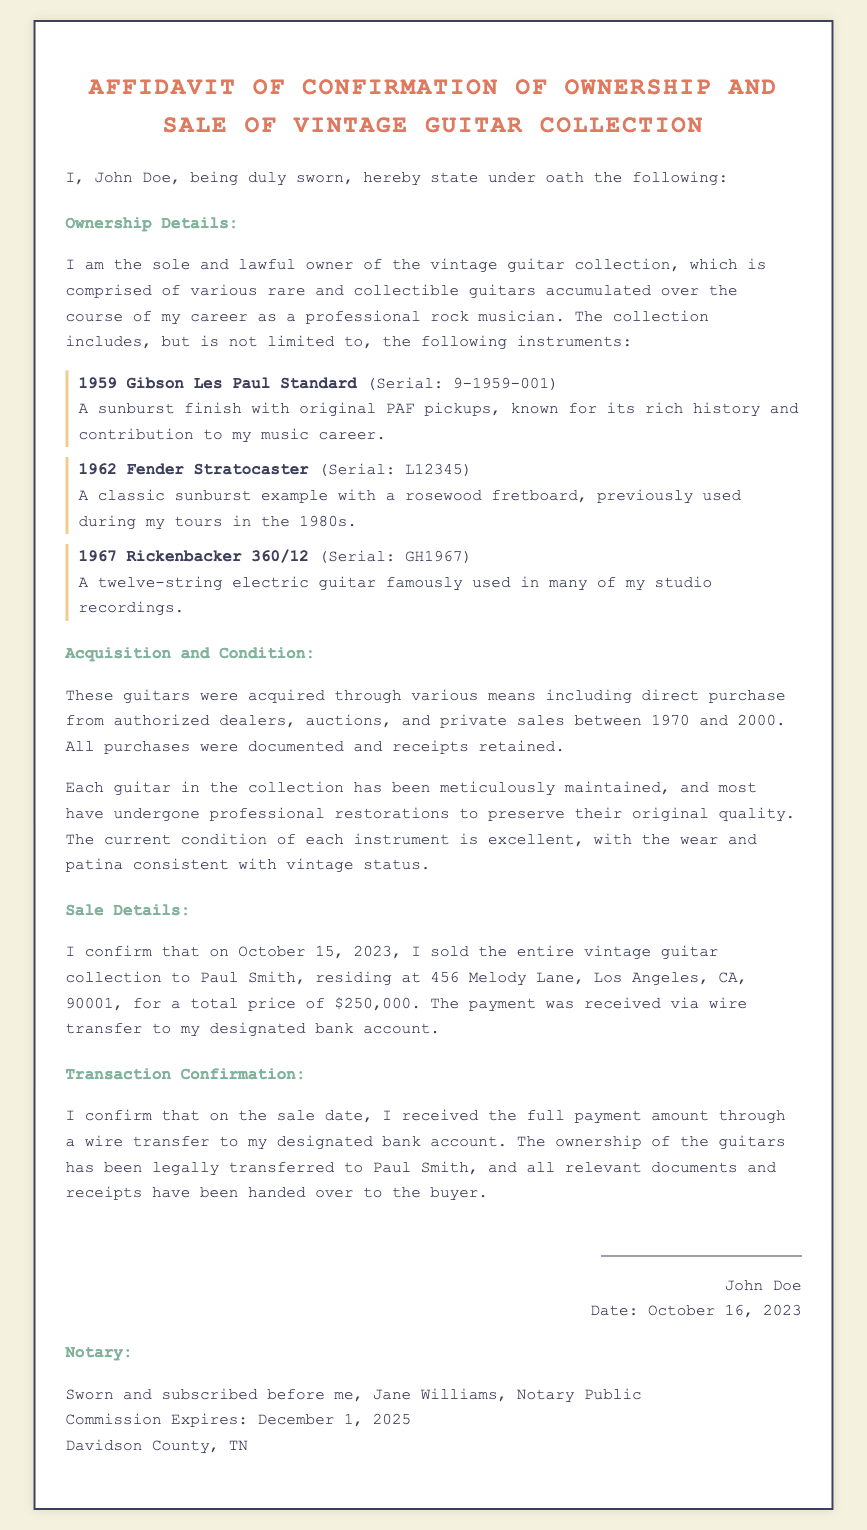What is the name of the owner? The owner of the vintage guitar collection is mentioned as John Doe in the affidavit.
Answer: John Doe What is the date of the sale? The date of the sale of the vintage guitar collection is clearly stated in the document.
Answer: October 15, 2023 Who is the buyer of the guitar collection? The buyer's name is provided in the sale details section of the affidavit.
Answer: Paul Smith What is the total sale price? The document specifies the price for which the guitar collection was sold.
Answer: $250,000 What instrument has the serial number 9-1959-001? The document lists specific instruments along with their serial numbers.
Answer: 1959 Gibson Les Paul Standard What location is associated with the buyer? The affidavit provides a complete address for the buyer of the guitar collection.
Answer: 456 Melody Lane, Los Angeles, CA, 90001 What is the condition of the guitars? The general condition of the guitars is described as part of the acquisition and condition section.
Answer: Excellent Who notarized the affidavit? The document includes the name of the notary who witnessed the affidavit.
Answer: Jane Williams When does the notary's commission expire? The expiration date of the notary's commission is provided in the notary section.
Answer: December 1, 2025 